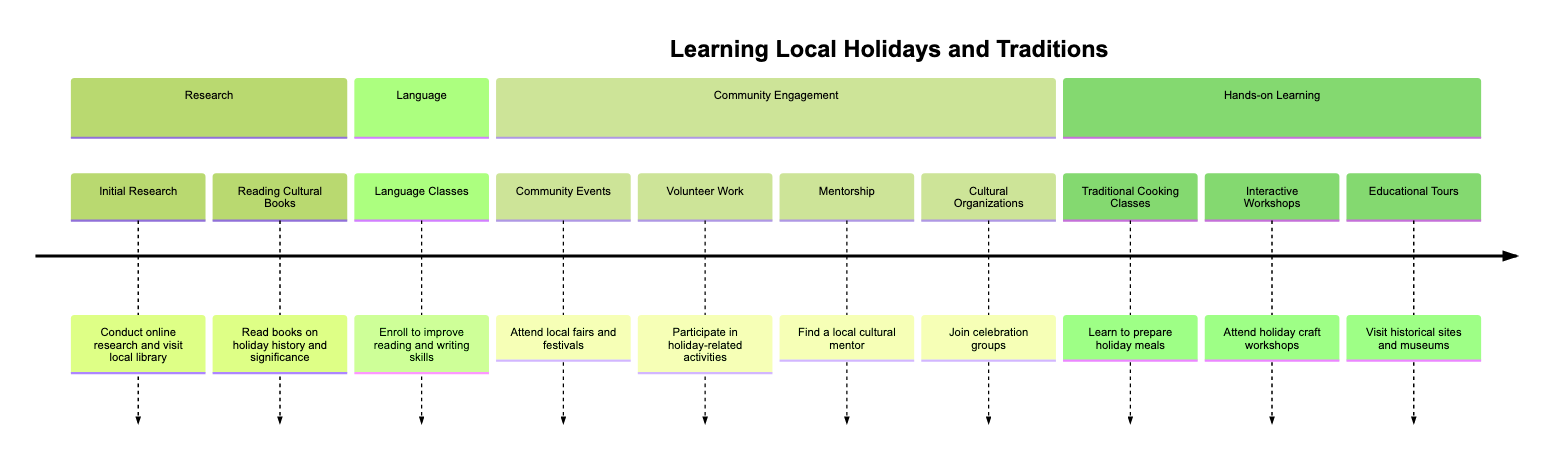What is the first step in the timeline? The first step listed in the timeline is "Initial Research," which includes conducting online research and visiting the local library to understand holidays and traditions.
Answer: Initial Research How many steps are there in total? The timeline consists of ten individual steps that outline the process of obtaining and learning about local holidays and traditions.
Answer: 10 What step involves attending local fairs and festivals? The step that involves attending local fairs and festivals is titled "Community Events," which emphasizes participation to observe and learn about holiday celebrations firsthand.
Answer: Community Events Which step emphasizes improving reading and writing skills? The step focused on improving reading and writing skills is "Language Classes," which encourages enrollment in language classes to better understand local customs.
Answer: Language Classes What type of activities are included in the "Hands-on Learning" section? The "Hands-on Learning" section includes various practical activities like traditional cooking classes, interactive workshops, and educational tours, all aimed at providing tactile learning experiences related to local traditions.
Answer: Cooking classes, Workshops, and Tours What is the last step in the timeline? The last step outlined in the timeline is "Educational Tours," which involves participating in tours of historical sites and museums to gain insights into cultural heritage.
Answer: Educational Tours Which step suggests finding a local cultural mentor? The step that suggests finding a local cultural mentor is termed "Mentorship," where one can join a program or be guided by a local resident regarding important holidays and traditions.
Answer: Mentorship How is "Cultural Organizations" relevant to the timeline? The "Cultural Organizations" step is relevant as it encourages joining groups focused on celebrating local traditions and holidays, thus fostering community engagement and connecting with the culture.
Answer: Join cultural organizations What is the common theme of the sections in the timeline? The common theme among all the sections in the timeline is learning and assimilating into the local culture through various methods, such as research, community engagement, language learning, and hands-on experiences.
Answer: Learning local culture 